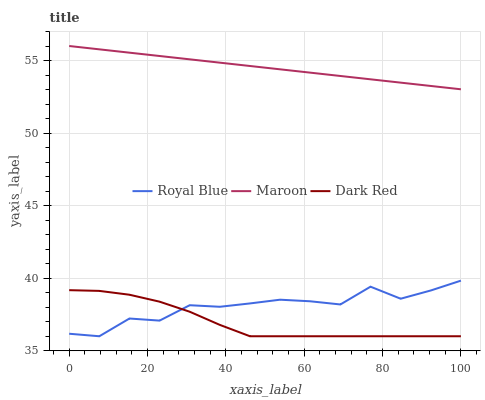Does Dark Red have the minimum area under the curve?
Answer yes or no. Yes. Does Maroon have the maximum area under the curve?
Answer yes or no. Yes. Does Maroon have the minimum area under the curve?
Answer yes or no. No. Does Dark Red have the maximum area under the curve?
Answer yes or no. No. Is Maroon the smoothest?
Answer yes or no. Yes. Is Royal Blue the roughest?
Answer yes or no. Yes. Is Dark Red the smoothest?
Answer yes or no. No. Is Dark Red the roughest?
Answer yes or no. No. Does Royal Blue have the lowest value?
Answer yes or no. Yes. Does Maroon have the lowest value?
Answer yes or no. No. Does Maroon have the highest value?
Answer yes or no. Yes. Does Dark Red have the highest value?
Answer yes or no. No. Is Royal Blue less than Maroon?
Answer yes or no. Yes. Is Maroon greater than Royal Blue?
Answer yes or no. Yes. Does Royal Blue intersect Dark Red?
Answer yes or no. Yes. Is Royal Blue less than Dark Red?
Answer yes or no. No. Is Royal Blue greater than Dark Red?
Answer yes or no. No. Does Royal Blue intersect Maroon?
Answer yes or no. No. 